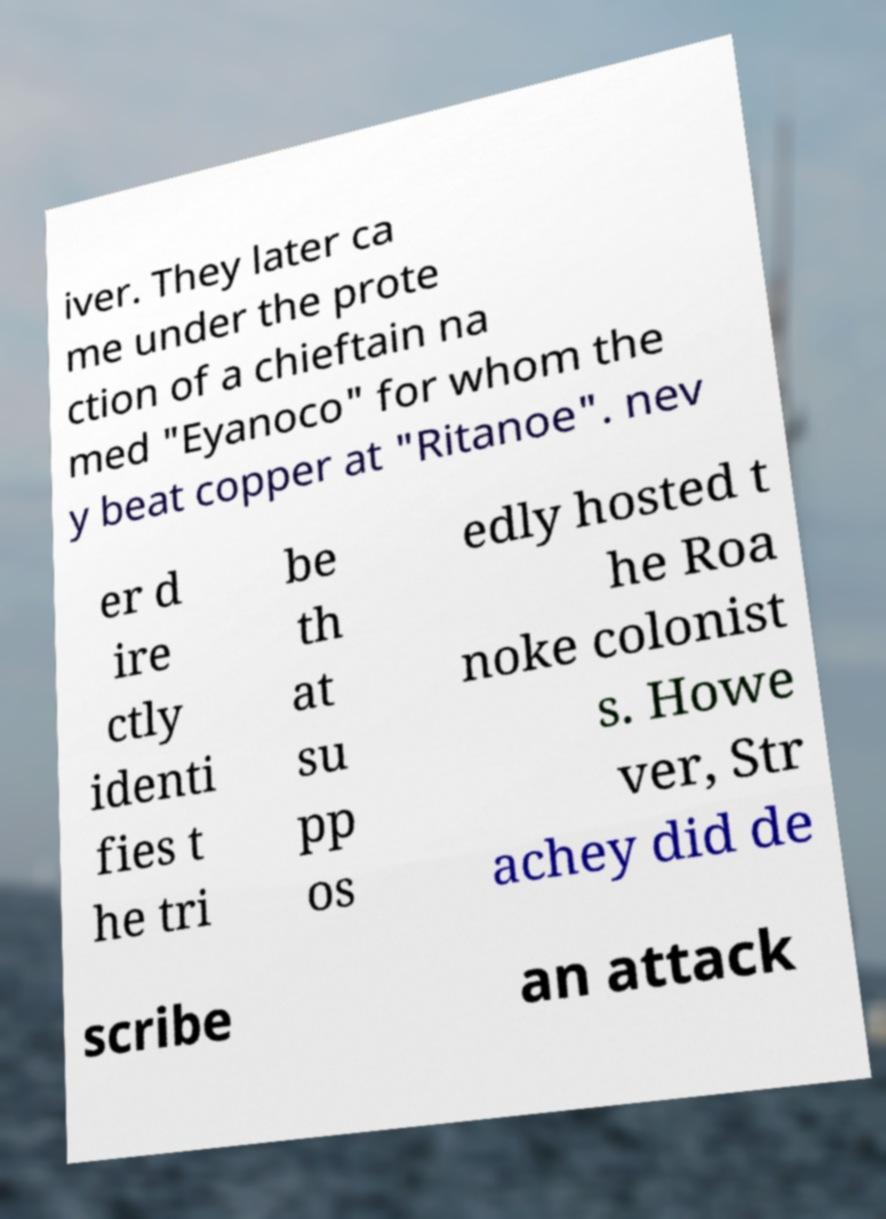Could you extract and type out the text from this image? iver. They later ca me under the prote ction of a chieftain na med "Eyanoco" for whom the y beat copper at "Ritanoe". nev er d ire ctly identi fies t he tri be th at su pp os edly hosted t he Roa noke colonist s. Howe ver, Str achey did de scribe an attack 